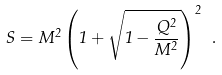Convert formula to latex. <formula><loc_0><loc_0><loc_500><loc_500>S = M ^ { 2 } \left ( 1 + \sqrt { 1 - \frac { Q ^ { 2 } } { M ^ { 2 } } } \right ) ^ { 2 } \ .</formula> 